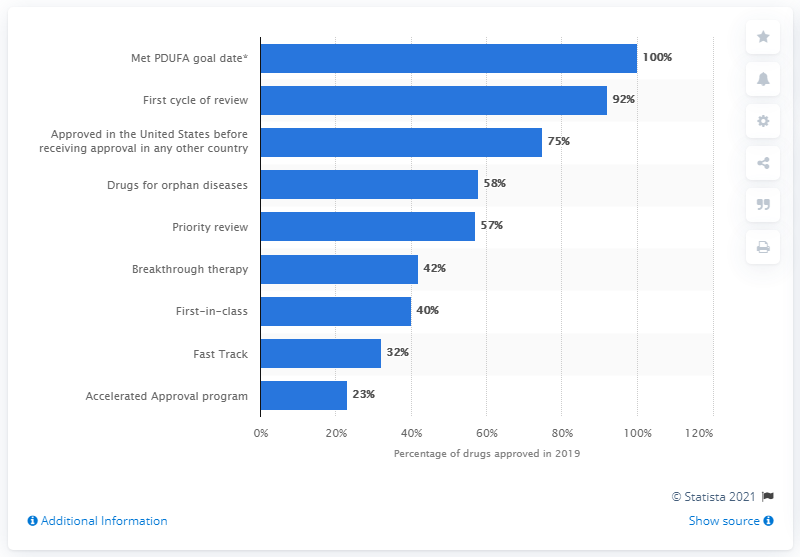List a handful of essential elements in this visual. According to a study, 58% of approved drugs were for orphan diseases. 100% of drugs approved by CDER met the PDUFA goal date for approval. 